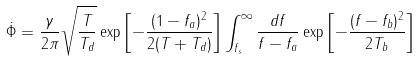<formula> <loc_0><loc_0><loc_500><loc_500>\dot { \Phi } = \frac { \gamma } { 2 \pi } \sqrt { \frac { T } { T _ { d } } } \exp \left [ - \frac { ( 1 - f _ { a } ) ^ { 2 } } { 2 ( T + T _ { d } ) } \right ] \int _ { f _ { s } } ^ { \infty } \frac { d f } { f - f _ { a } } \exp \left [ - \frac { ( f - f _ { b } ) ^ { 2 } } { 2 T _ { b } } \right ]</formula> 